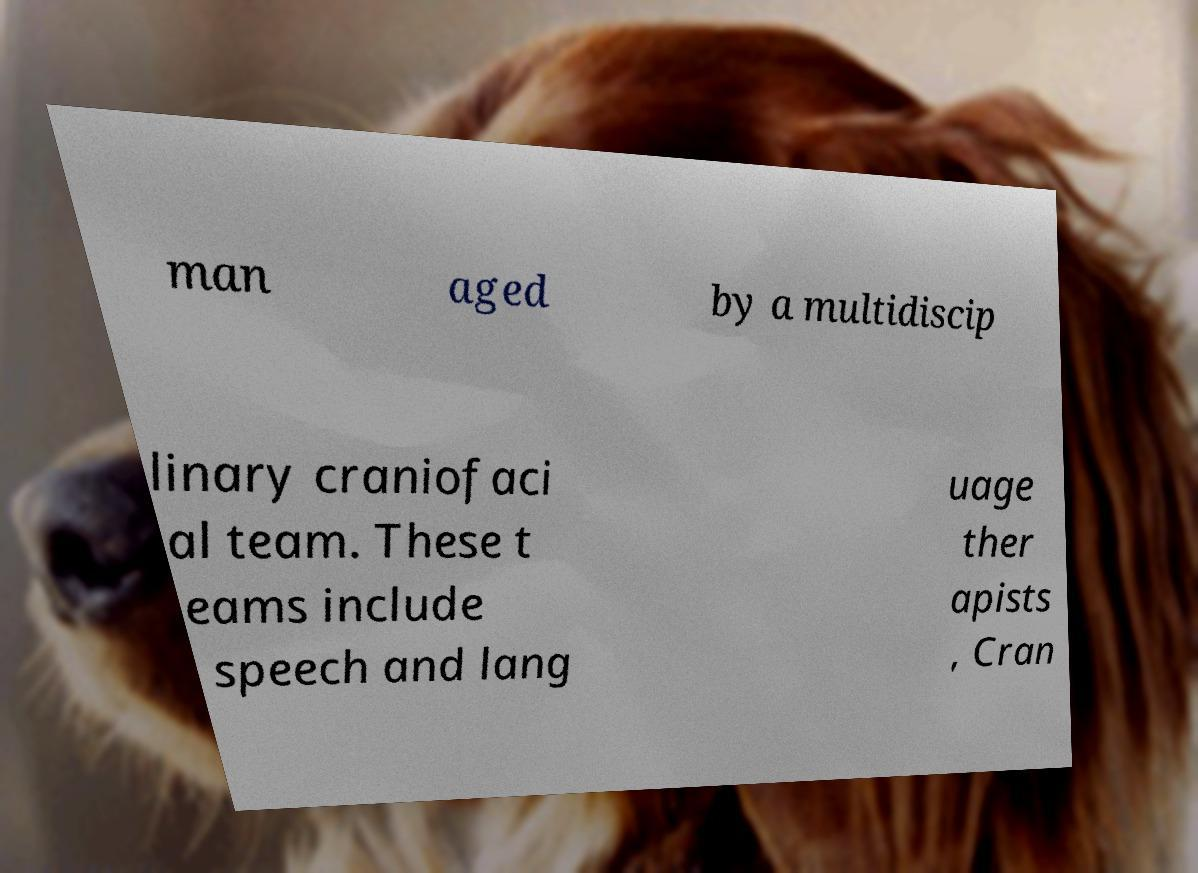Can you accurately transcribe the text from the provided image for me? man aged by a multidiscip linary craniofaci al team. These t eams include speech and lang uage ther apists , Cran 